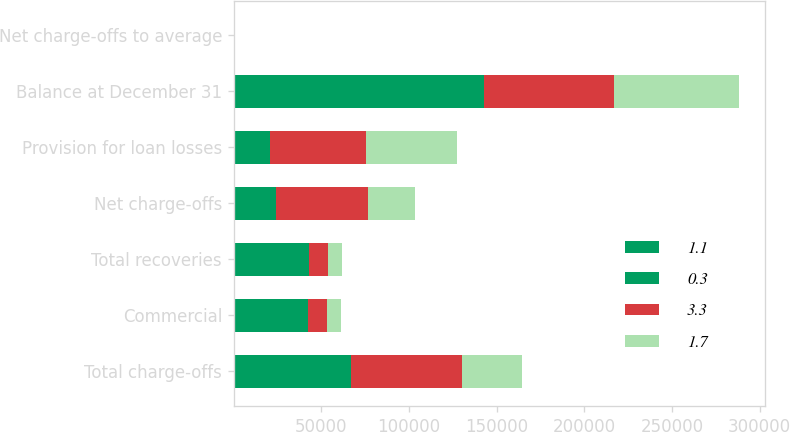<chart> <loc_0><loc_0><loc_500><loc_500><stacked_bar_chart><ecel><fcel>Total charge-offs<fcel>Commercial<fcel>Total recoveries<fcel>Net charge-offs<fcel>Provision for loan losses<fcel>Balance at December 31<fcel>Net charge-offs to average<nl><fcel>1.1<fcel>27932<fcel>22175<fcel>22175<fcel>5757<fcel>3882<fcel>70500<fcel>0.3<nl><fcel>0.3<fcel>38785<fcel>20408<fcel>20636<fcel>18149<fcel>16724<fcel>72375<fcel>1.1<nl><fcel>3.3<fcel>63380<fcel>10507<fcel>10778<fcel>52602<fcel>54602<fcel>73800<fcel>3.3<nl><fcel>1.7<fcel>34508<fcel>7849<fcel>7901<fcel>26607<fcel>52407<fcel>71800<fcel>1.7<nl></chart> 